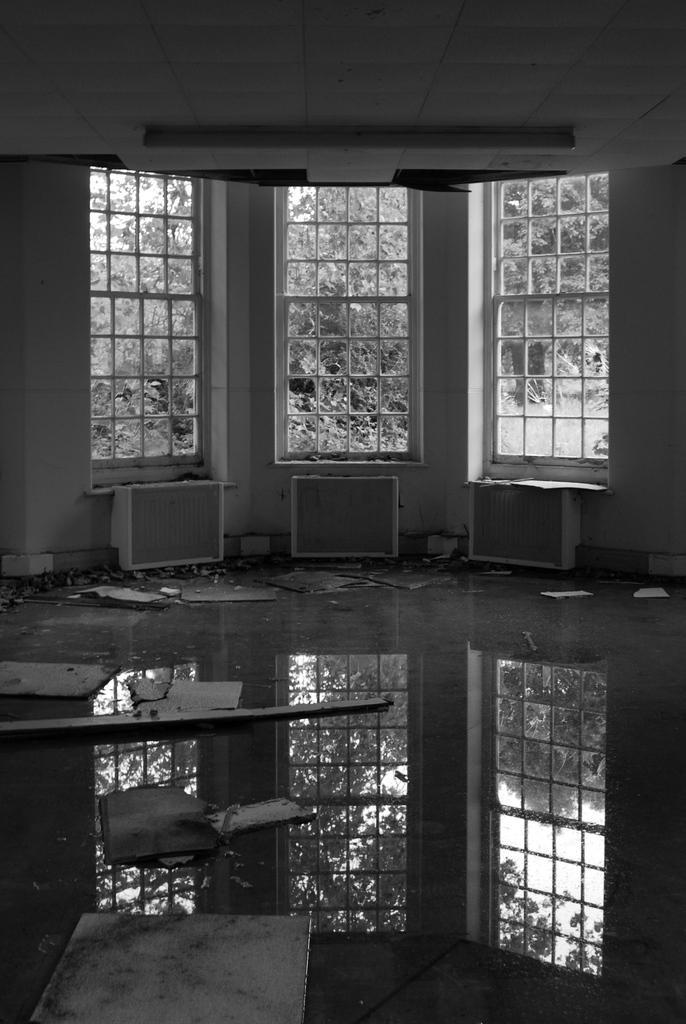Describe this image in one or two sentences. This is a room. In this room there is a wall with windows. There are boxes near the windows. On the floor there is water. We can see the reflection of windows on the floor. Also there are some boards on the floor. Through the windows we can see trees. 